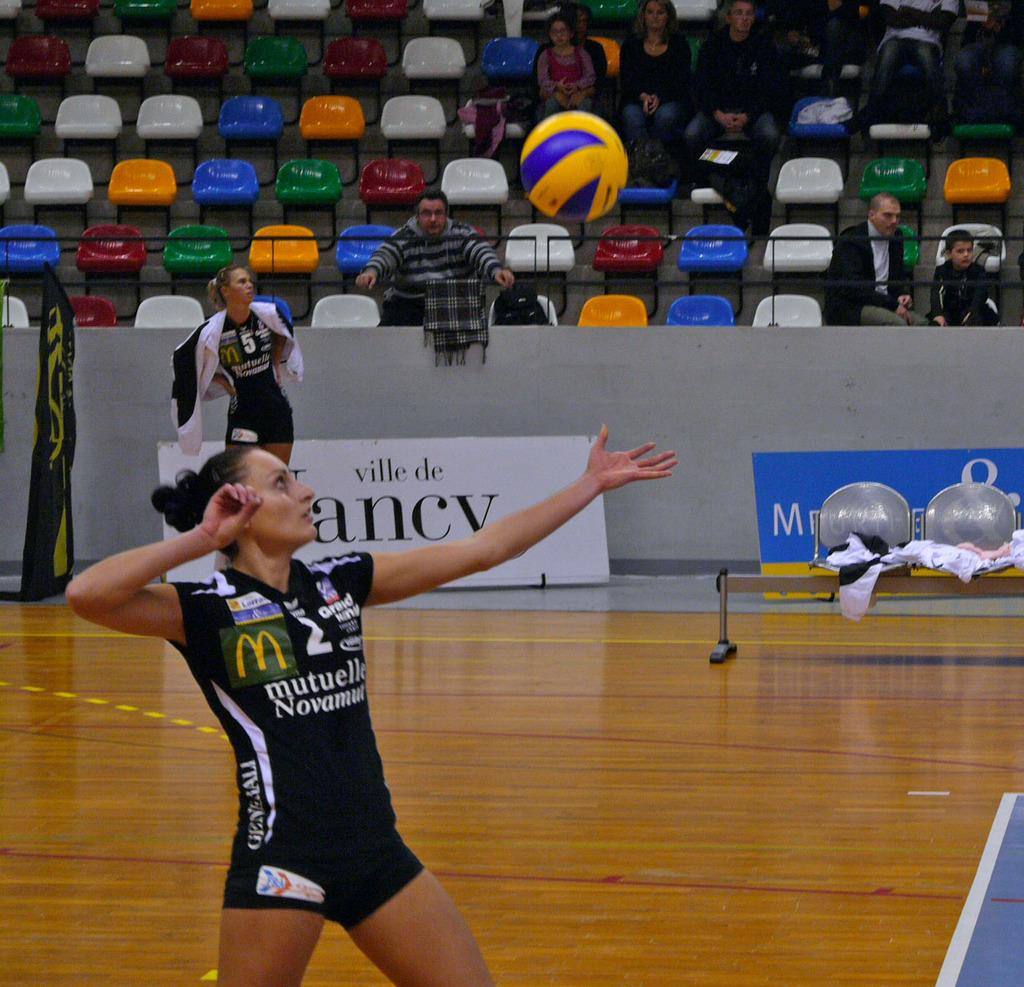<image>
Create a compact narrative representing the image presented. Female volleyball player #2 wearing jersey with McDonald's logo. 